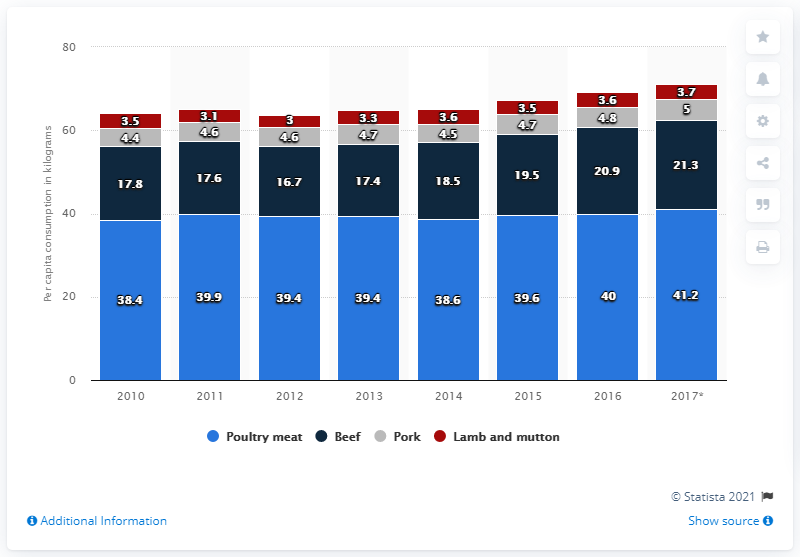Mention a couple of crucial points in this snapshot. It is indicated by the red color that lamb and mutton are the meats in question. The difference between the maximum and minimum consumption of beef is 4.6 kilograms. 